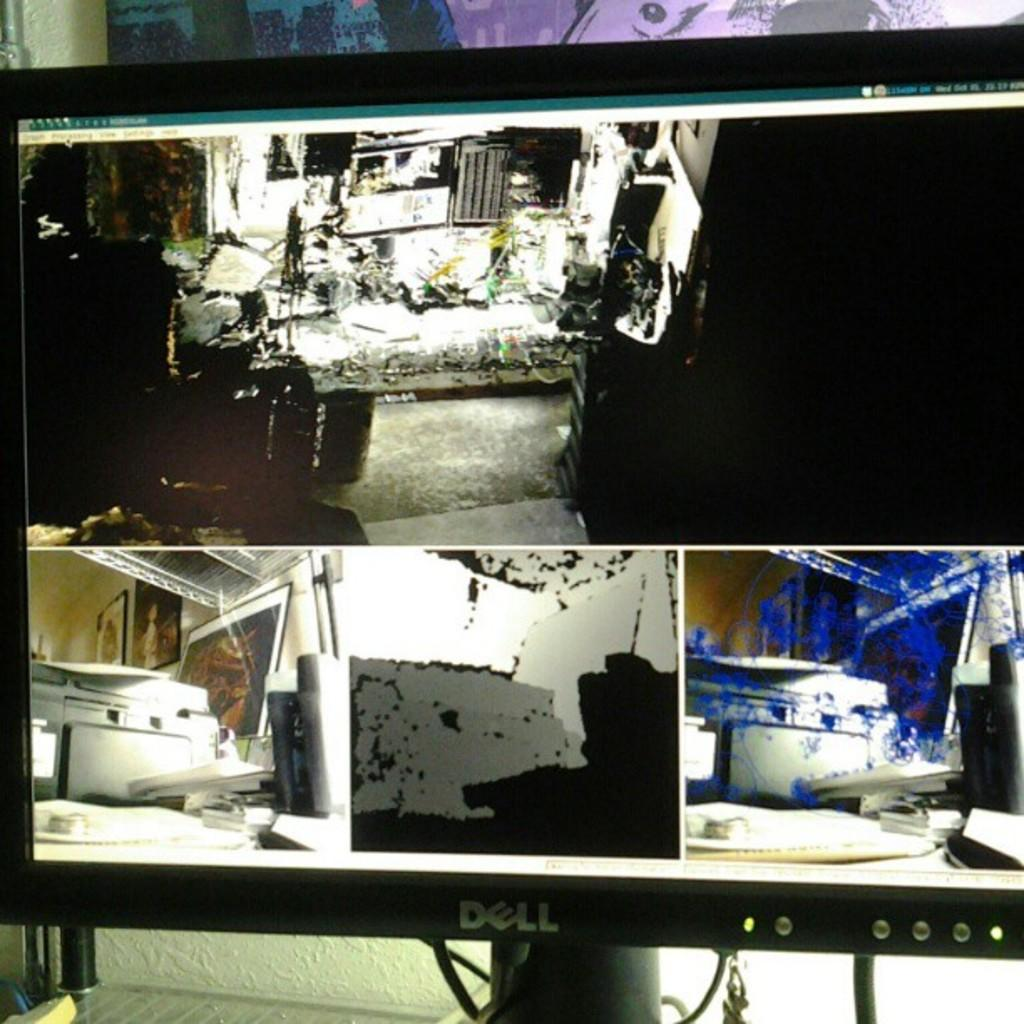<image>
Present a compact description of the photo's key features. A Dell computer monitor showing security camera footage. 